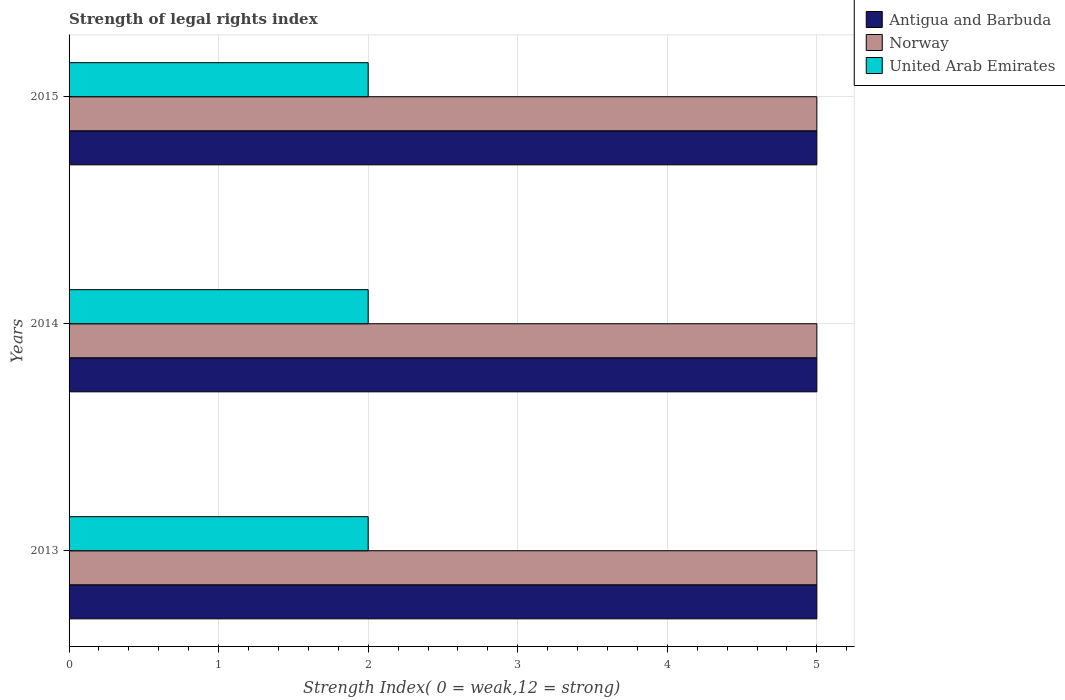How many different coloured bars are there?
Provide a succinct answer. 3. How many bars are there on the 1st tick from the top?
Offer a terse response. 3. How many bars are there on the 2nd tick from the bottom?
Your answer should be compact. 3. In how many cases, is the number of bars for a given year not equal to the number of legend labels?
Ensure brevity in your answer.  0. What is the strength index in Norway in 2015?
Offer a terse response. 5. Across all years, what is the maximum strength index in Antigua and Barbuda?
Give a very brief answer. 5. Across all years, what is the minimum strength index in Norway?
Give a very brief answer. 5. What is the total strength index in United Arab Emirates in the graph?
Offer a terse response. 6. What is the difference between the strength index in Norway in 2014 and that in 2015?
Your response must be concise. 0. What is the difference between the strength index in United Arab Emirates in 2014 and the strength index in Antigua and Barbuda in 2015?
Offer a terse response. -3. In the year 2013, what is the difference between the strength index in United Arab Emirates and strength index in Norway?
Offer a very short reply. -3. In how many years, is the strength index in United Arab Emirates greater than 3.2 ?
Make the answer very short. 0. What is the difference between the highest and the second highest strength index in Norway?
Ensure brevity in your answer.  0. Is the sum of the strength index in United Arab Emirates in 2013 and 2014 greater than the maximum strength index in Norway across all years?
Your answer should be very brief. No. What does the 3rd bar from the top in 2014 represents?
Provide a succinct answer. Antigua and Barbuda. What does the 3rd bar from the bottom in 2015 represents?
Your answer should be very brief. United Arab Emirates. How many years are there in the graph?
Your answer should be very brief. 3. What is the difference between two consecutive major ticks on the X-axis?
Your response must be concise. 1. Are the values on the major ticks of X-axis written in scientific E-notation?
Offer a terse response. No. Does the graph contain any zero values?
Keep it short and to the point. No. Does the graph contain grids?
Your answer should be very brief. Yes. How many legend labels are there?
Provide a short and direct response. 3. How are the legend labels stacked?
Your answer should be very brief. Vertical. What is the title of the graph?
Provide a short and direct response. Strength of legal rights index. What is the label or title of the X-axis?
Offer a very short reply. Strength Index( 0 = weak,12 = strong). What is the Strength Index( 0 = weak,12 = strong) in Antigua and Barbuda in 2013?
Your answer should be compact. 5. What is the Strength Index( 0 = weak,12 = strong) of Norway in 2013?
Keep it short and to the point. 5. What is the Strength Index( 0 = weak,12 = strong) in United Arab Emirates in 2013?
Your answer should be very brief. 2. What is the Strength Index( 0 = weak,12 = strong) of Antigua and Barbuda in 2015?
Make the answer very short. 5. What is the Strength Index( 0 = weak,12 = strong) of Norway in 2015?
Your response must be concise. 5. Across all years, what is the maximum Strength Index( 0 = weak,12 = strong) in Antigua and Barbuda?
Offer a terse response. 5. Across all years, what is the maximum Strength Index( 0 = weak,12 = strong) of Norway?
Your response must be concise. 5. Across all years, what is the maximum Strength Index( 0 = weak,12 = strong) of United Arab Emirates?
Ensure brevity in your answer.  2. Across all years, what is the minimum Strength Index( 0 = weak,12 = strong) of Antigua and Barbuda?
Provide a short and direct response. 5. Across all years, what is the minimum Strength Index( 0 = weak,12 = strong) of Norway?
Make the answer very short. 5. Across all years, what is the minimum Strength Index( 0 = weak,12 = strong) of United Arab Emirates?
Make the answer very short. 2. What is the total Strength Index( 0 = weak,12 = strong) in Antigua and Barbuda in the graph?
Make the answer very short. 15. What is the total Strength Index( 0 = weak,12 = strong) in Norway in the graph?
Your answer should be compact. 15. What is the difference between the Strength Index( 0 = weak,12 = strong) in Antigua and Barbuda in 2013 and that in 2014?
Give a very brief answer. 0. What is the difference between the Strength Index( 0 = weak,12 = strong) of United Arab Emirates in 2013 and that in 2014?
Your response must be concise. 0. What is the difference between the Strength Index( 0 = weak,12 = strong) in Norway in 2013 and that in 2015?
Your response must be concise. 0. What is the difference between the Strength Index( 0 = weak,12 = strong) of United Arab Emirates in 2013 and that in 2015?
Your answer should be very brief. 0. What is the difference between the Strength Index( 0 = weak,12 = strong) of Antigua and Barbuda in 2014 and that in 2015?
Offer a very short reply. 0. What is the difference between the Strength Index( 0 = weak,12 = strong) of Norway in 2014 and that in 2015?
Keep it short and to the point. 0. What is the difference between the Strength Index( 0 = weak,12 = strong) in Antigua and Barbuda in 2013 and the Strength Index( 0 = weak,12 = strong) in United Arab Emirates in 2014?
Your answer should be compact. 3. What is the difference between the Strength Index( 0 = weak,12 = strong) of Norway in 2013 and the Strength Index( 0 = weak,12 = strong) of United Arab Emirates in 2014?
Make the answer very short. 3. What is the difference between the Strength Index( 0 = weak,12 = strong) in Antigua and Barbuda in 2013 and the Strength Index( 0 = weak,12 = strong) in United Arab Emirates in 2015?
Your response must be concise. 3. What is the difference between the Strength Index( 0 = weak,12 = strong) in Norway in 2013 and the Strength Index( 0 = weak,12 = strong) in United Arab Emirates in 2015?
Your answer should be very brief. 3. What is the average Strength Index( 0 = weak,12 = strong) of Norway per year?
Ensure brevity in your answer.  5. In the year 2013, what is the difference between the Strength Index( 0 = weak,12 = strong) in Norway and Strength Index( 0 = weak,12 = strong) in United Arab Emirates?
Ensure brevity in your answer.  3. In the year 2014, what is the difference between the Strength Index( 0 = weak,12 = strong) of Antigua and Barbuda and Strength Index( 0 = weak,12 = strong) of Norway?
Your answer should be compact. 0. In the year 2014, what is the difference between the Strength Index( 0 = weak,12 = strong) of Norway and Strength Index( 0 = weak,12 = strong) of United Arab Emirates?
Provide a short and direct response. 3. In the year 2015, what is the difference between the Strength Index( 0 = weak,12 = strong) in Antigua and Barbuda and Strength Index( 0 = weak,12 = strong) in Norway?
Your answer should be compact. 0. In the year 2015, what is the difference between the Strength Index( 0 = weak,12 = strong) of Antigua and Barbuda and Strength Index( 0 = weak,12 = strong) of United Arab Emirates?
Ensure brevity in your answer.  3. What is the ratio of the Strength Index( 0 = weak,12 = strong) of Antigua and Barbuda in 2013 to that in 2015?
Your answer should be very brief. 1. What is the ratio of the Strength Index( 0 = weak,12 = strong) of Antigua and Barbuda in 2014 to that in 2015?
Keep it short and to the point. 1. What is the ratio of the Strength Index( 0 = weak,12 = strong) of Norway in 2014 to that in 2015?
Offer a terse response. 1. What is the ratio of the Strength Index( 0 = weak,12 = strong) in United Arab Emirates in 2014 to that in 2015?
Your answer should be very brief. 1. What is the difference between the highest and the second highest Strength Index( 0 = weak,12 = strong) of United Arab Emirates?
Provide a short and direct response. 0. What is the difference between the highest and the lowest Strength Index( 0 = weak,12 = strong) of Antigua and Barbuda?
Keep it short and to the point. 0. 